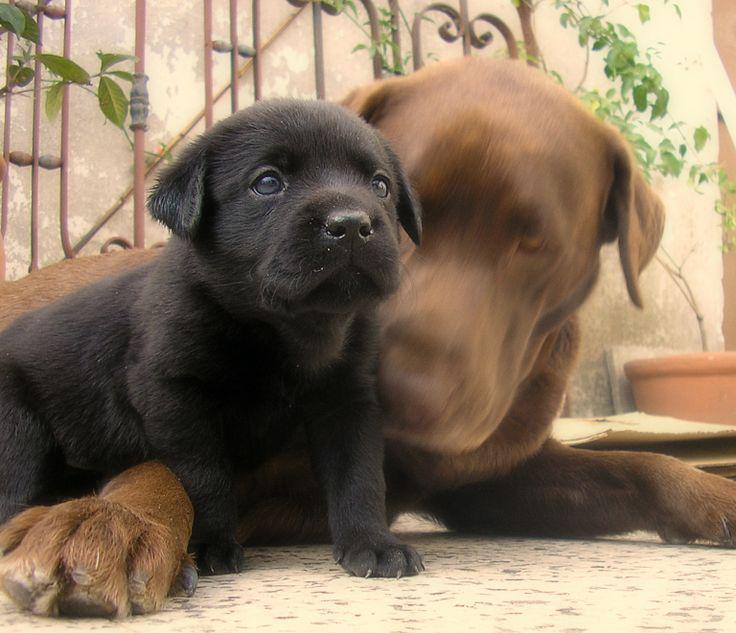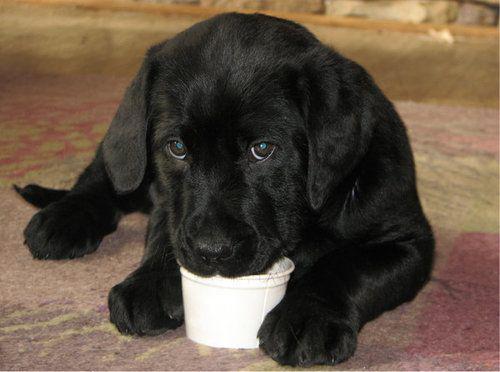The first image is the image on the left, the second image is the image on the right. Evaluate the accuracy of this statement regarding the images: "At least one of the images in each set features a lone black pup.". Is it true? Answer yes or no. Yes. 